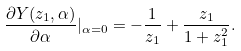<formula> <loc_0><loc_0><loc_500><loc_500>\frac { \partial { Y } ( z _ { 1 } , \alpha ) } { \partial \alpha } | _ { \alpha = 0 } = - \frac { 1 } { z _ { 1 } } + \frac { z _ { 1 } } { 1 + z _ { 1 } ^ { 2 } } .</formula> 